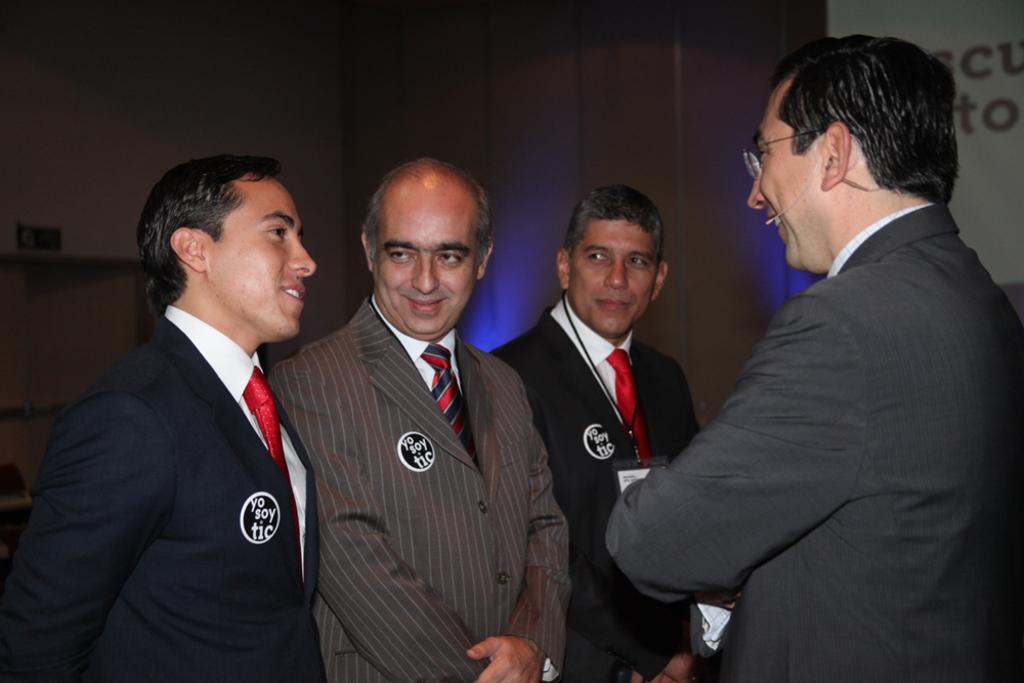Describe this image in one or two sentences. In this image I can see four men are standing and I can see all of them are wearing suit, tie and shirt. I can also see smile on few faces. In the background I can see something is written over here. 